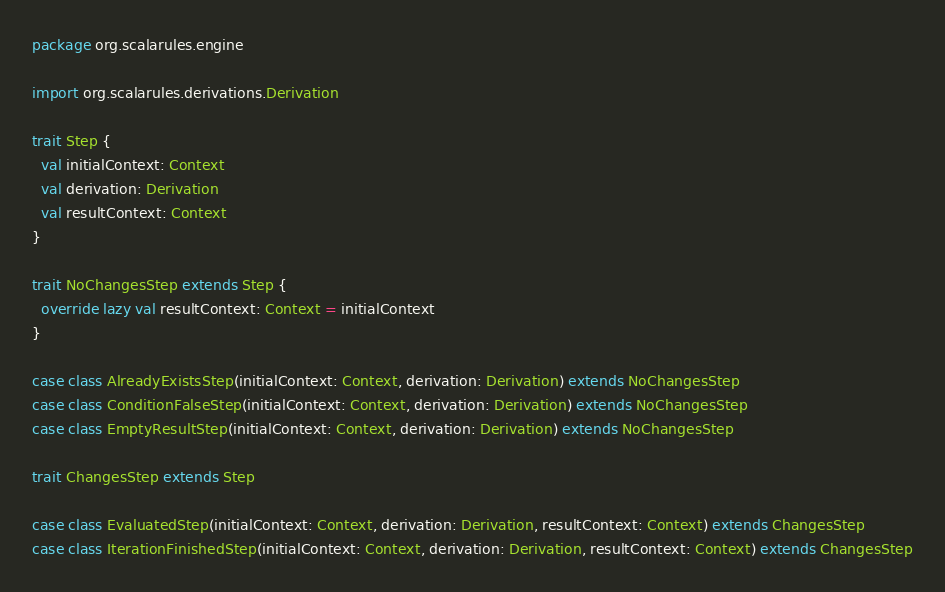<code> <loc_0><loc_0><loc_500><loc_500><_Scala_>package org.scalarules.engine

import org.scalarules.derivations.Derivation

trait Step {
  val initialContext: Context
  val derivation: Derivation
  val resultContext: Context
}

trait NoChangesStep extends Step {
  override lazy val resultContext: Context = initialContext
}

case class AlreadyExistsStep(initialContext: Context, derivation: Derivation) extends NoChangesStep
case class ConditionFalseStep(initialContext: Context, derivation: Derivation) extends NoChangesStep
case class EmptyResultStep(initialContext: Context, derivation: Derivation) extends NoChangesStep

trait ChangesStep extends Step

case class EvaluatedStep(initialContext: Context, derivation: Derivation, resultContext: Context) extends ChangesStep
case class IterationFinishedStep(initialContext: Context, derivation: Derivation, resultContext: Context) extends ChangesStep</code> 